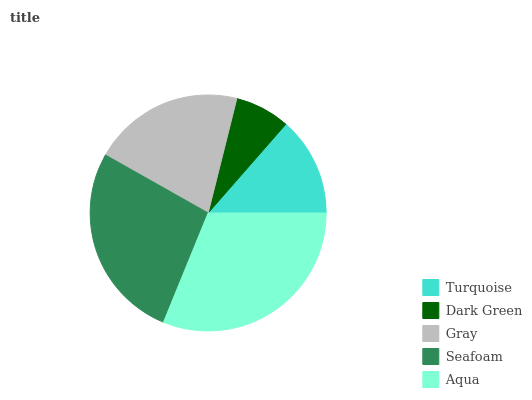Is Dark Green the minimum?
Answer yes or no. Yes. Is Aqua the maximum?
Answer yes or no. Yes. Is Gray the minimum?
Answer yes or no. No. Is Gray the maximum?
Answer yes or no. No. Is Gray greater than Dark Green?
Answer yes or no. Yes. Is Dark Green less than Gray?
Answer yes or no. Yes. Is Dark Green greater than Gray?
Answer yes or no. No. Is Gray less than Dark Green?
Answer yes or no. No. Is Gray the high median?
Answer yes or no. Yes. Is Gray the low median?
Answer yes or no. Yes. Is Aqua the high median?
Answer yes or no. No. Is Aqua the low median?
Answer yes or no. No. 